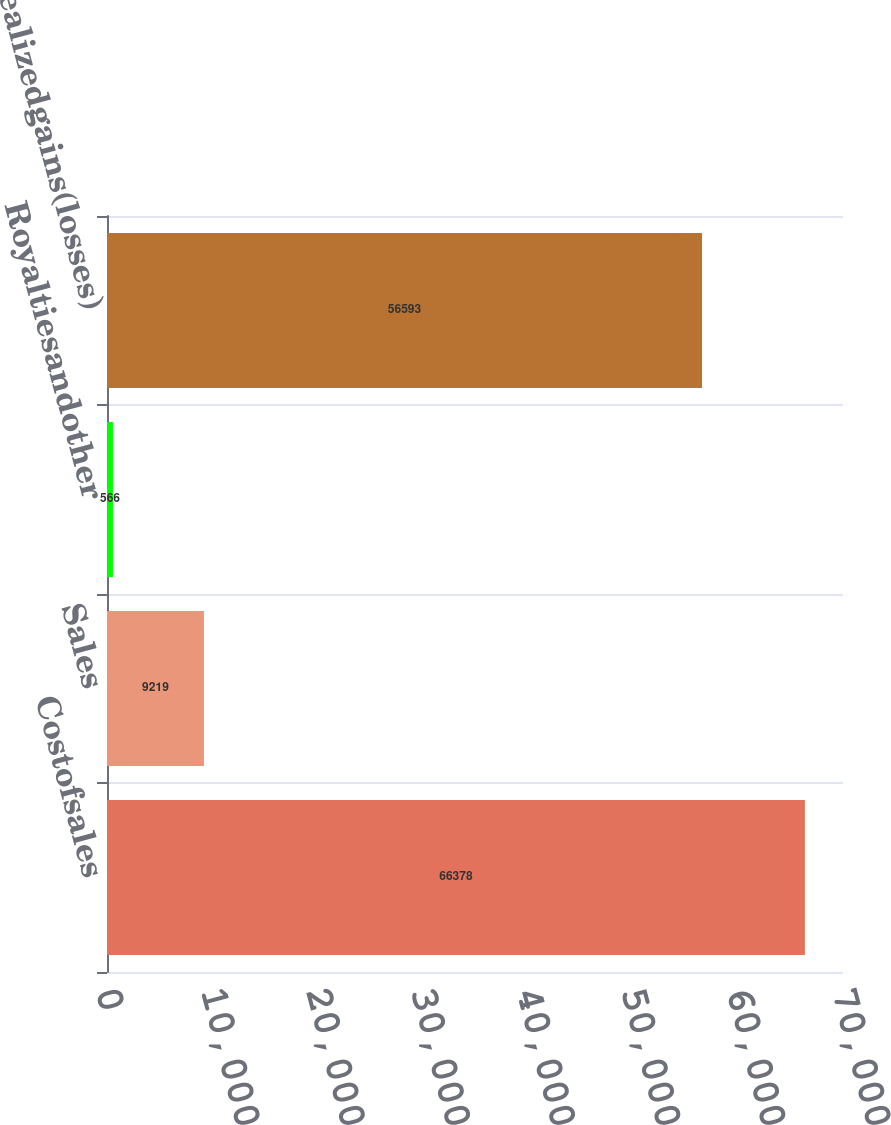Convert chart to OTSL. <chart><loc_0><loc_0><loc_500><loc_500><bar_chart><fcel>Costofsales<fcel>Sales<fcel>Royaltiesandother<fcel>Netrealizedgains(losses)<nl><fcel>66378<fcel>9219<fcel>566<fcel>56593<nl></chart> 